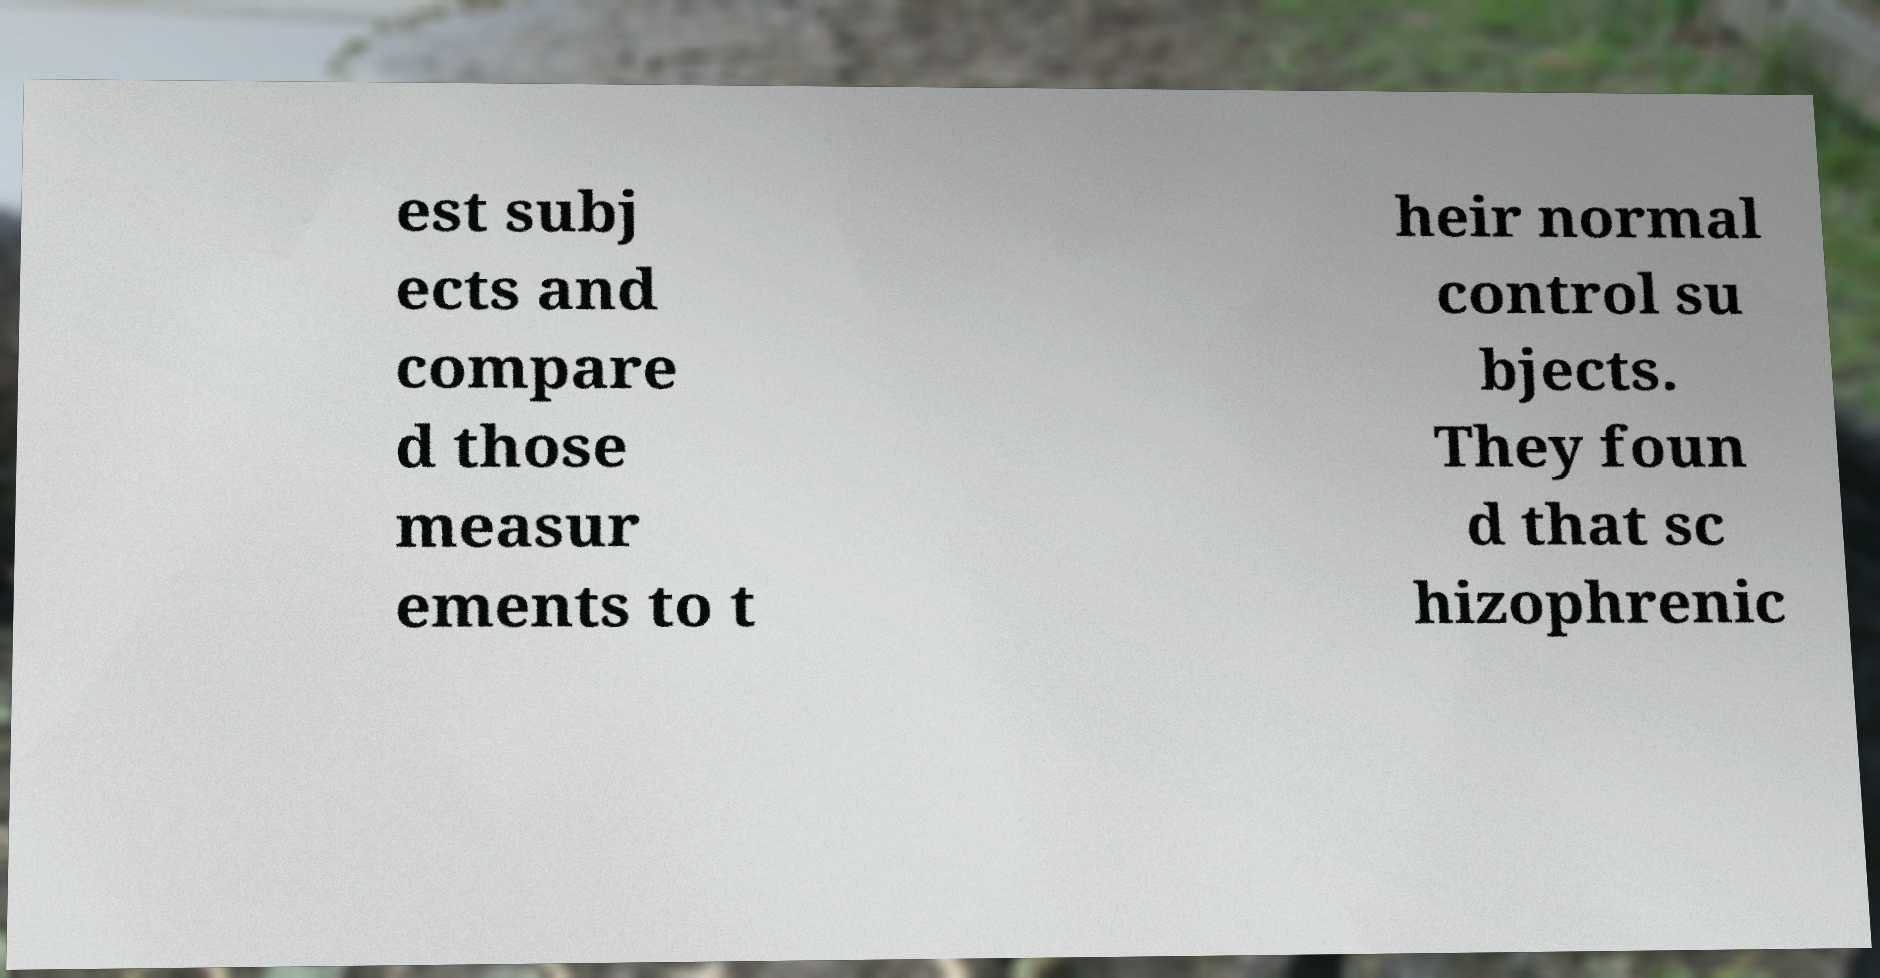For documentation purposes, I need the text within this image transcribed. Could you provide that? est subj ects and compare d those measur ements to t heir normal control su bjects. They foun d that sc hizophrenic 